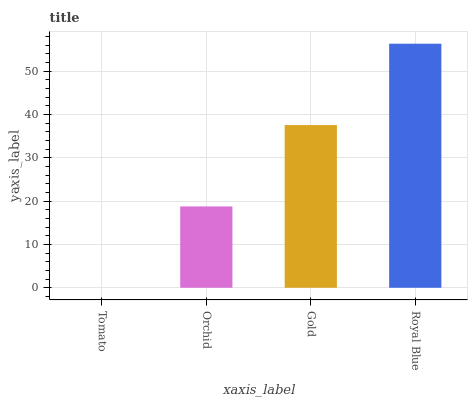Is Tomato the minimum?
Answer yes or no. Yes. Is Royal Blue the maximum?
Answer yes or no. Yes. Is Orchid the minimum?
Answer yes or no. No. Is Orchid the maximum?
Answer yes or no. No. Is Orchid greater than Tomato?
Answer yes or no. Yes. Is Tomato less than Orchid?
Answer yes or no. Yes. Is Tomato greater than Orchid?
Answer yes or no. No. Is Orchid less than Tomato?
Answer yes or no. No. Is Gold the high median?
Answer yes or no. Yes. Is Orchid the low median?
Answer yes or no. Yes. Is Orchid the high median?
Answer yes or no. No. Is Gold the low median?
Answer yes or no. No. 